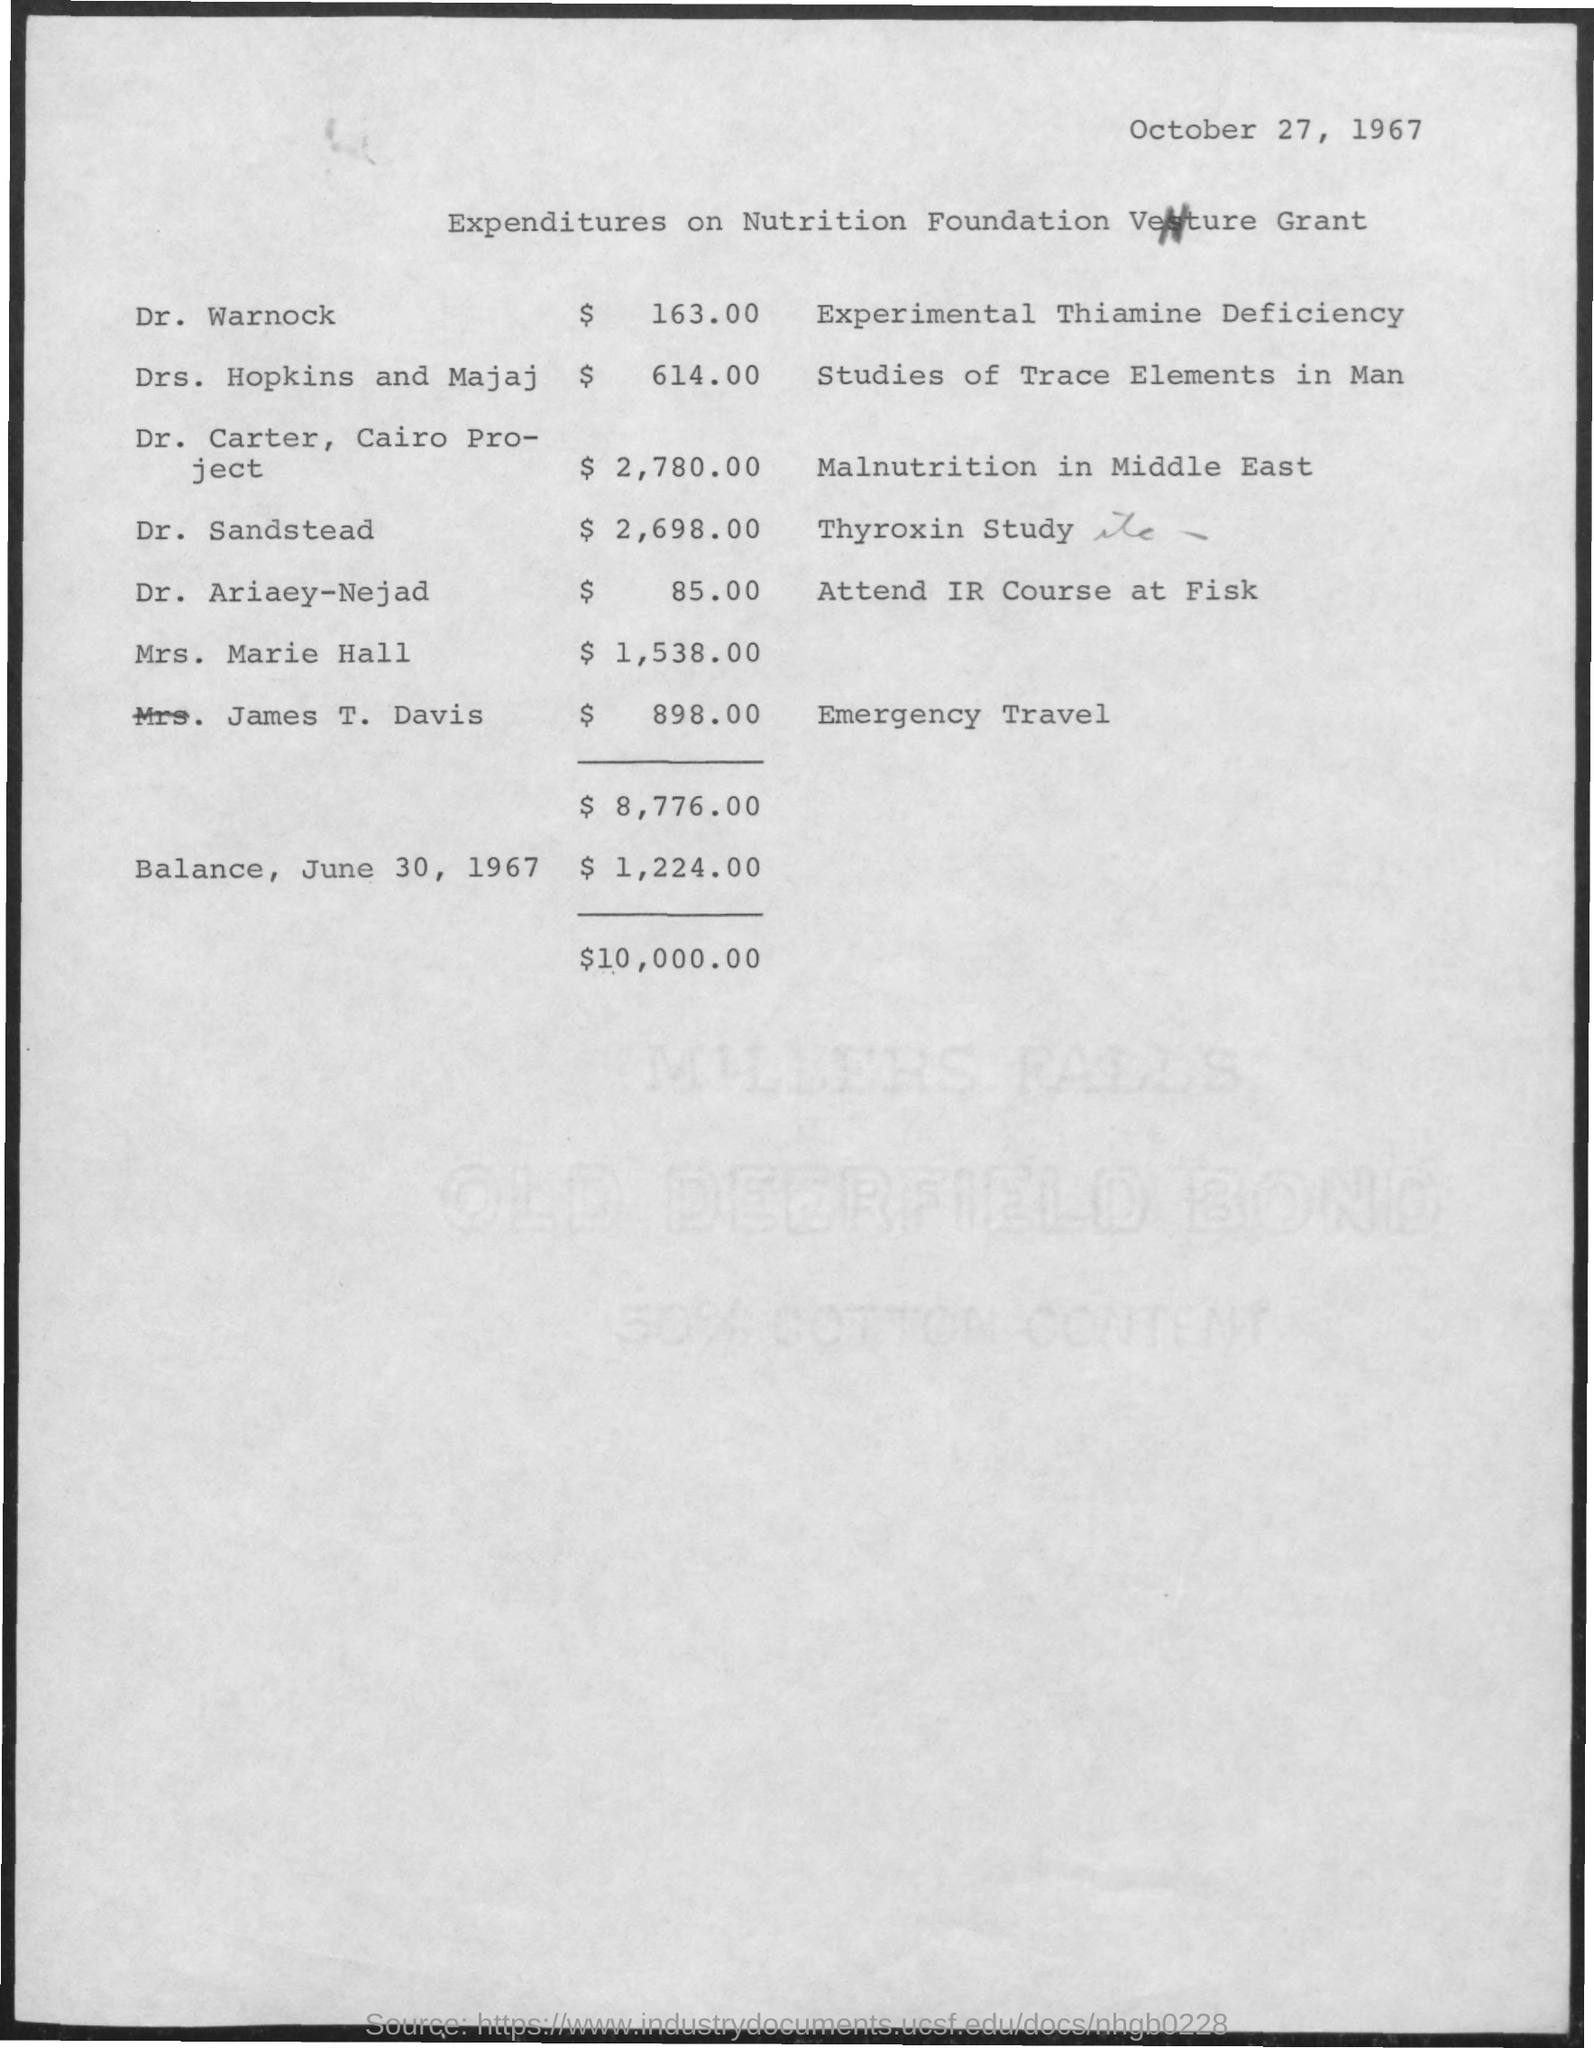Specify some key components in this picture. The amount for Dr. Ariaey-Nejad is $85.00. James T. Davis owes $898.00. The amount for Dr. Sandstead is $2,698.00. The date on the document is October 27, 1967. The amount for Drs. Hopkin and Majaj is $614.00 